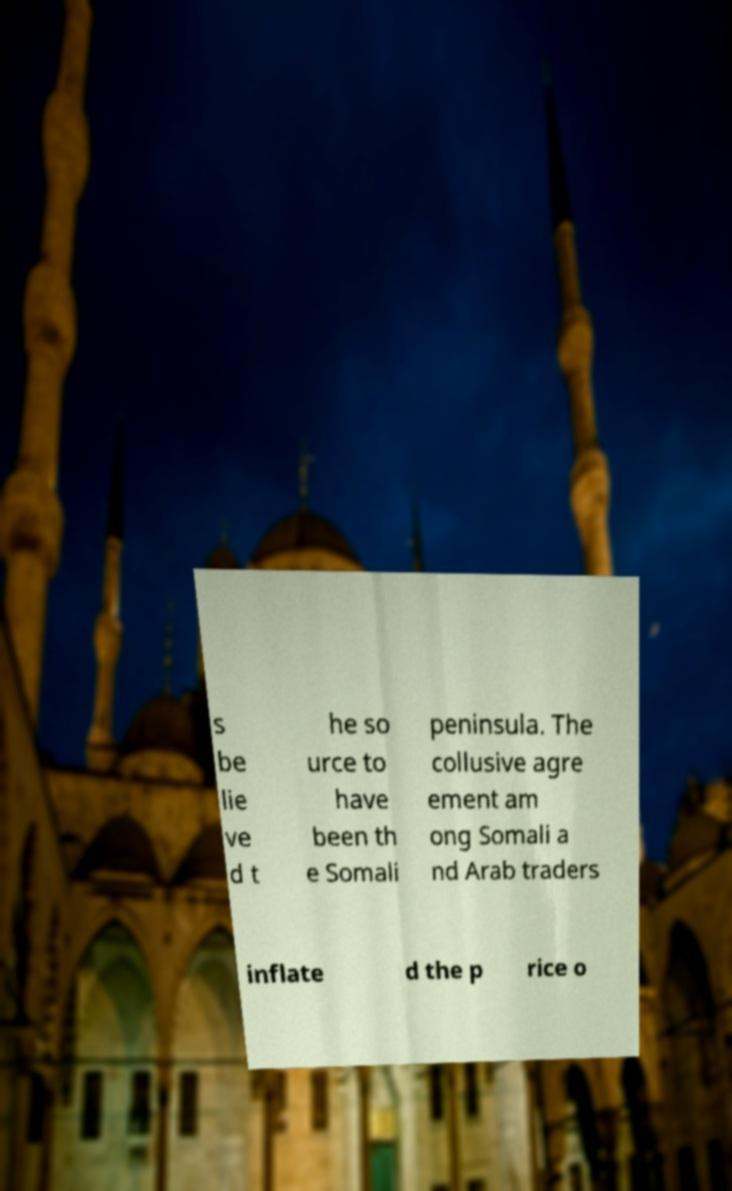Can you accurately transcribe the text from the provided image for me? s be lie ve d t he so urce to have been th e Somali peninsula. The collusive agre ement am ong Somali a nd Arab traders inflate d the p rice o 